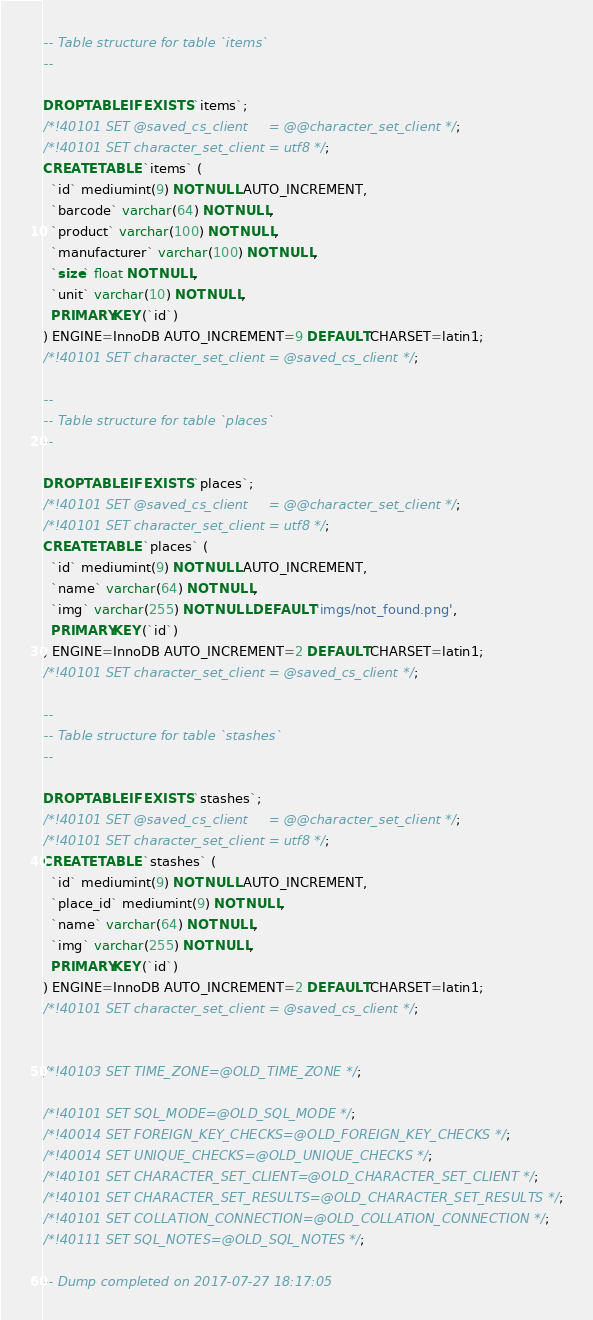<code> <loc_0><loc_0><loc_500><loc_500><_SQL_>-- Table structure for table `items`
--

DROP TABLE IF EXISTS `items`;
/*!40101 SET @saved_cs_client     = @@character_set_client */;
/*!40101 SET character_set_client = utf8 */;
CREATE TABLE `items` (
  `id` mediumint(9) NOT NULL AUTO_INCREMENT,
  `barcode` varchar(64) NOT NULL,
  `product` varchar(100) NOT NULL,
  `manufacturer` varchar(100) NOT NULL,
  `size` float NOT NULL,
  `unit` varchar(10) NOT NULL,
  PRIMARY KEY (`id`)
) ENGINE=InnoDB AUTO_INCREMENT=9 DEFAULT CHARSET=latin1;
/*!40101 SET character_set_client = @saved_cs_client */;

--
-- Table structure for table `places`
--

DROP TABLE IF EXISTS `places`;
/*!40101 SET @saved_cs_client     = @@character_set_client */;
/*!40101 SET character_set_client = utf8 */;
CREATE TABLE `places` (
  `id` mediumint(9) NOT NULL AUTO_INCREMENT,
  `name` varchar(64) NOT NULL,
  `img` varchar(255) NOT NULL DEFAULT 'imgs/not_found.png',
  PRIMARY KEY (`id`)
) ENGINE=InnoDB AUTO_INCREMENT=2 DEFAULT CHARSET=latin1;
/*!40101 SET character_set_client = @saved_cs_client */;

--
-- Table structure for table `stashes`
--

DROP TABLE IF EXISTS `stashes`;
/*!40101 SET @saved_cs_client     = @@character_set_client */;
/*!40101 SET character_set_client = utf8 */;
CREATE TABLE `stashes` (
  `id` mediumint(9) NOT NULL AUTO_INCREMENT,
  `place_id` mediumint(9) NOT NULL,
  `name` varchar(64) NOT NULL,
  `img` varchar(255) NOT NULL,
  PRIMARY KEY (`id`)
) ENGINE=InnoDB AUTO_INCREMENT=2 DEFAULT CHARSET=latin1;
/*!40101 SET character_set_client = @saved_cs_client */;


/*!40103 SET TIME_ZONE=@OLD_TIME_ZONE */;

/*!40101 SET SQL_MODE=@OLD_SQL_MODE */;
/*!40014 SET FOREIGN_KEY_CHECKS=@OLD_FOREIGN_KEY_CHECKS */;
/*!40014 SET UNIQUE_CHECKS=@OLD_UNIQUE_CHECKS */;
/*!40101 SET CHARACTER_SET_CLIENT=@OLD_CHARACTER_SET_CLIENT */;
/*!40101 SET CHARACTER_SET_RESULTS=@OLD_CHARACTER_SET_RESULTS */;
/*!40101 SET COLLATION_CONNECTION=@OLD_COLLATION_CONNECTION */;
/*!40111 SET SQL_NOTES=@OLD_SQL_NOTES */;

-- Dump completed on 2017-07-27 18:17:05
</code> 